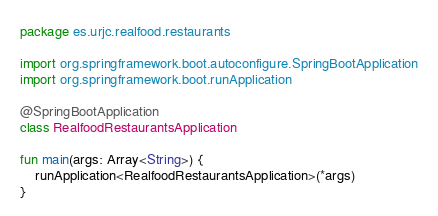<code> <loc_0><loc_0><loc_500><loc_500><_Kotlin_>package es.urjc.realfood.restaurants

import org.springframework.boot.autoconfigure.SpringBootApplication
import org.springframework.boot.runApplication

@SpringBootApplication
class RealfoodRestaurantsApplication

fun main(args: Array<String>) {
    runApplication<RealfoodRestaurantsApplication>(*args)
}
</code> 